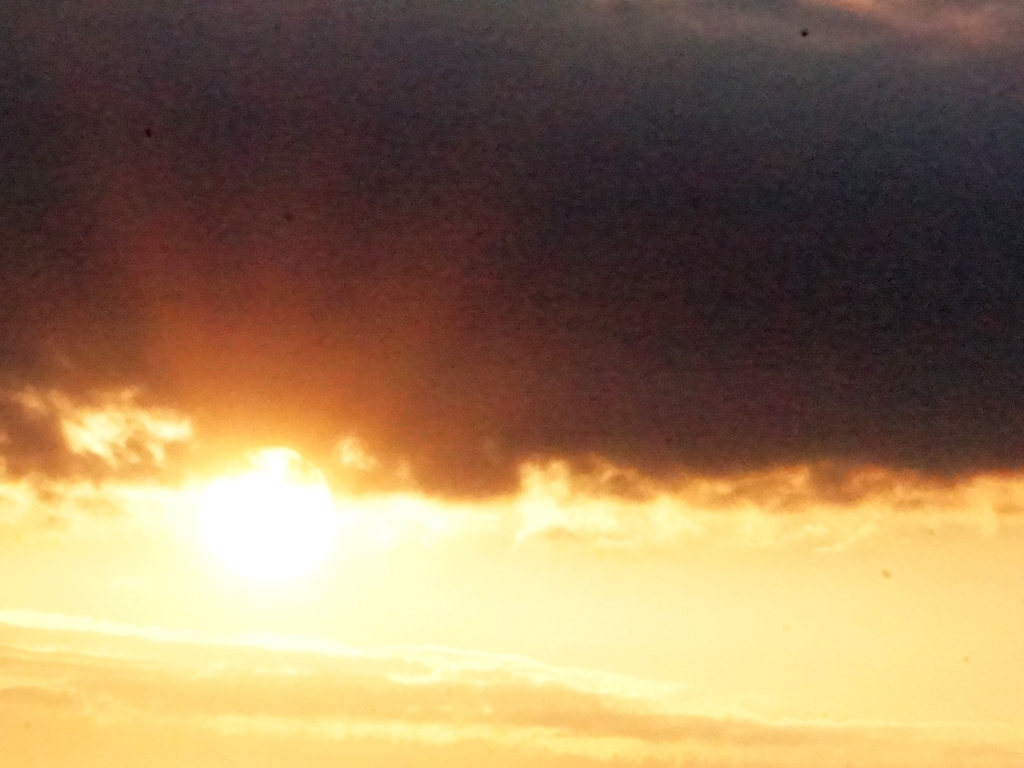Could this image be used for any particular purpose? This image could be used for artistic inspiration, as a meditative background, or even as a visual representation in discussions about light and atmosphere in photography. It might also serve as a striking backdrop for quotes or text in graphic design projects. 